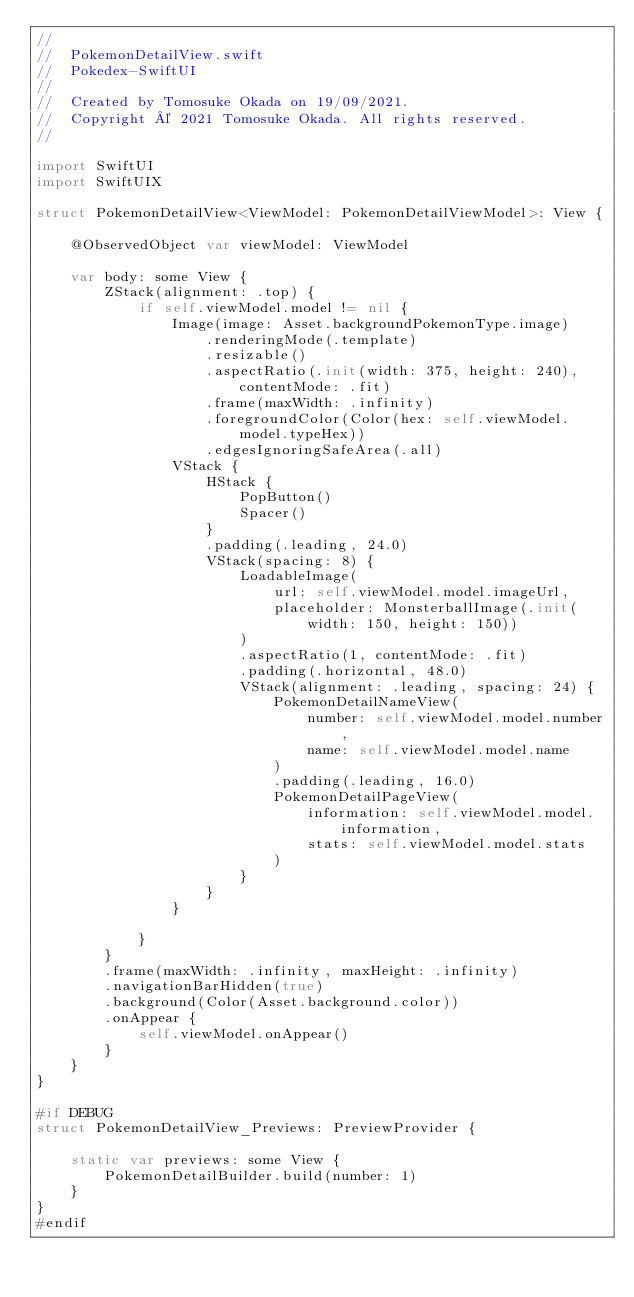Convert code to text. <code><loc_0><loc_0><loc_500><loc_500><_Swift_>//
//  PokemonDetailView.swift
//  Pokedex-SwiftUI
//
//  Created by Tomosuke Okada on 19/09/2021.
//  Copyright © 2021 Tomosuke Okada. All rights reserved.
//

import SwiftUI
import SwiftUIX

struct PokemonDetailView<ViewModel: PokemonDetailViewModel>: View {

    @ObservedObject var viewModel: ViewModel

    var body: some View {
        ZStack(alignment: .top) {
            if self.viewModel.model != nil {
                Image(image: Asset.backgroundPokemonType.image)
                    .renderingMode(.template)
                    .resizable()
                    .aspectRatio(.init(width: 375, height: 240), contentMode: .fit)
                    .frame(maxWidth: .infinity)
                    .foregroundColor(Color(hex: self.viewModel.model.typeHex))
                    .edgesIgnoringSafeArea(.all)
                VStack {
                    HStack {
                        PopButton()
                        Spacer()
                    }
                    .padding(.leading, 24.0)
                    VStack(spacing: 8) {
                        LoadableImage(
                            url: self.viewModel.model.imageUrl,
                            placeholder: MonsterballImage(.init(width: 150, height: 150))
                        )
                        .aspectRatio(1, contentMode: .fit)
                        .padding(.horizontal, 48.0)
                        VStack(alignment: .leading, spacing: 24) {
                            PokemonDetailNameView(
                                number: self.viewModel.model.number,
                                name: self.viewModel.model.name
                            )
                            .padding(.leading, 16.0)
                            PokemonDetailPageView(
                                information: self.viewModel.model.information,
                                stats: self.viewModel.model.stats
                            )
                        }
                    }
                }

            }
        }
        .frame(maxWidth: .infinity, maxHeight: .infinity)
        .navigationBarHidden(true)
        .background(Color(Asset.background.color))
        .onAppear {
            self.viewModel.onAppear()
        }
    }
}

#if DEBUG
struct PokemonDetailView_Previews: PreviewProvider {

    static var previews: some View {
        PokemonDetailBuilder.build(number: 1)
    }
}
#endif
</code> 